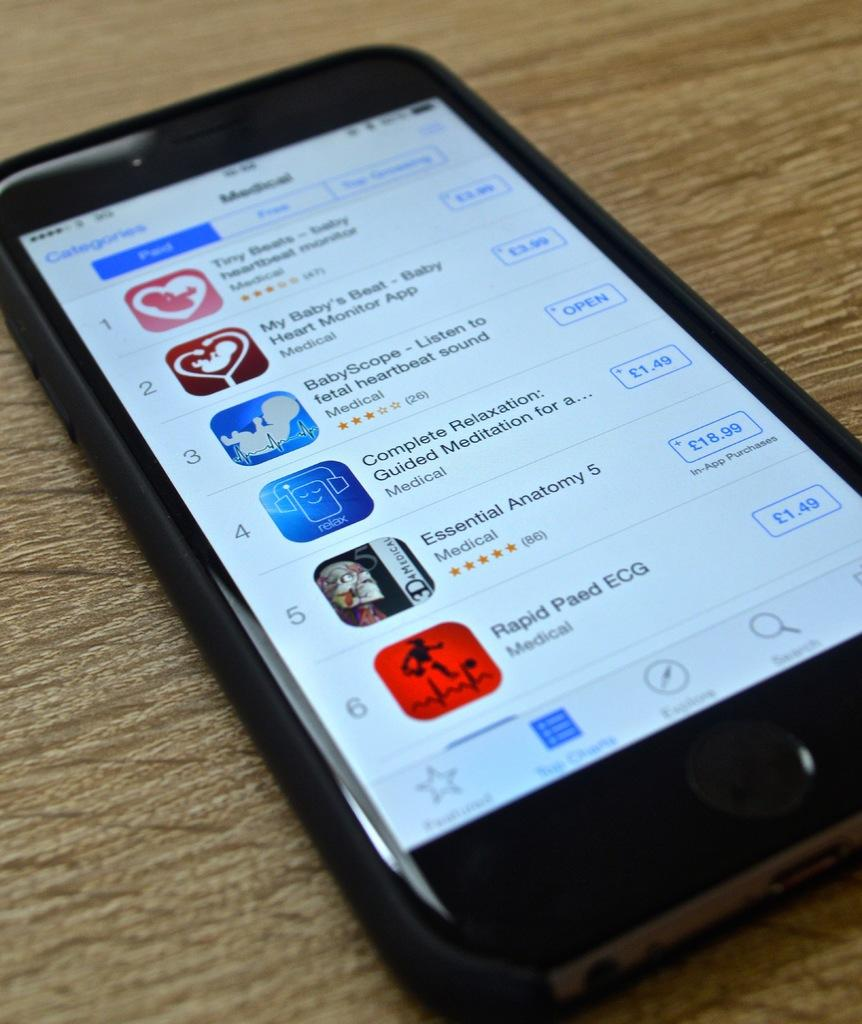What type of phone is in the image? There is a black color phone in the image. Where is the phone located? The phone is placed on a brown color table. What can be seen on the screen of the phone? There is text visible on the screen of the phone. Is there a guitar being played by a maid in the image? No, there is no guitar or maid present in the image. 